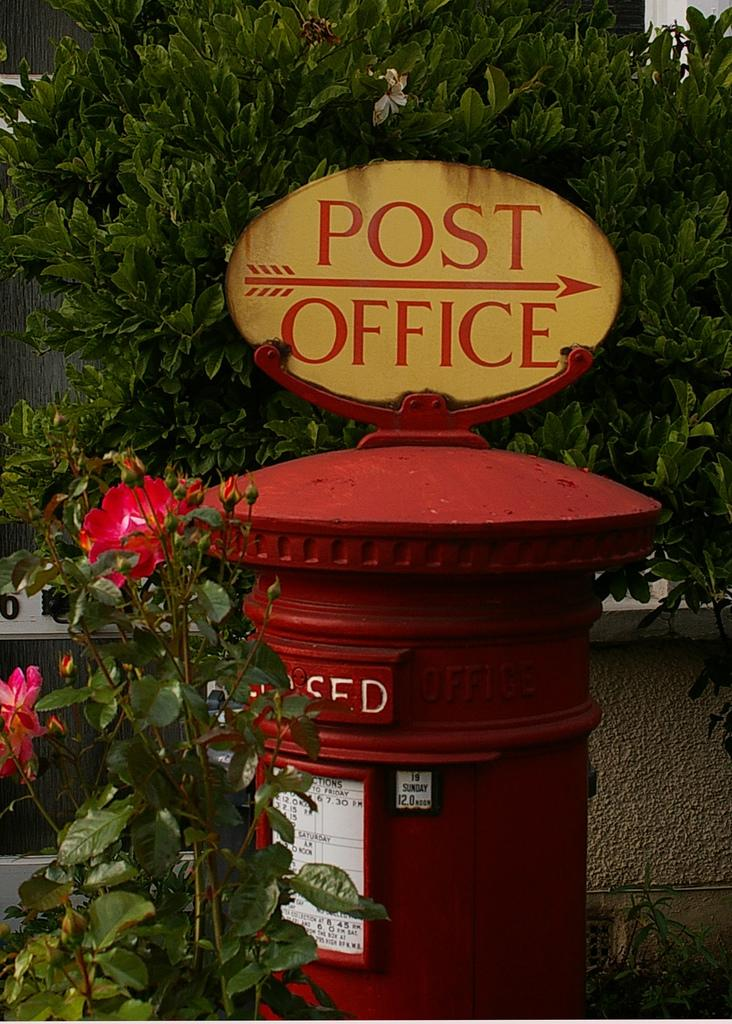What object is the main focus of the image? There is a post box in the image. What additional information is provided about the post box? The post box has a name board and stickers. What can be seen in the image besides the post box? There are flowers and plants in the image. What is visible in the background of the image? There is a tree and a wall in the background of the image. What type of coat is the post box wearing in the image? Post boxes do not wear coats, as they are inanimate objects. 